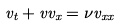Convert formula to latex. <formula><loc_0><loc_0><loc_500><loc_500>v _ { t } + v v _ { x } = \nu v _ { x x }</formula> 